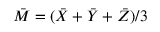Convert formula to latex. <formula><loc_0><loc_0><loc_500><loc_500>{ \bar { M } } = ( { \bar { X } } + { \bar { Y } } + { \bar { Z } } ) / 3</formula> 